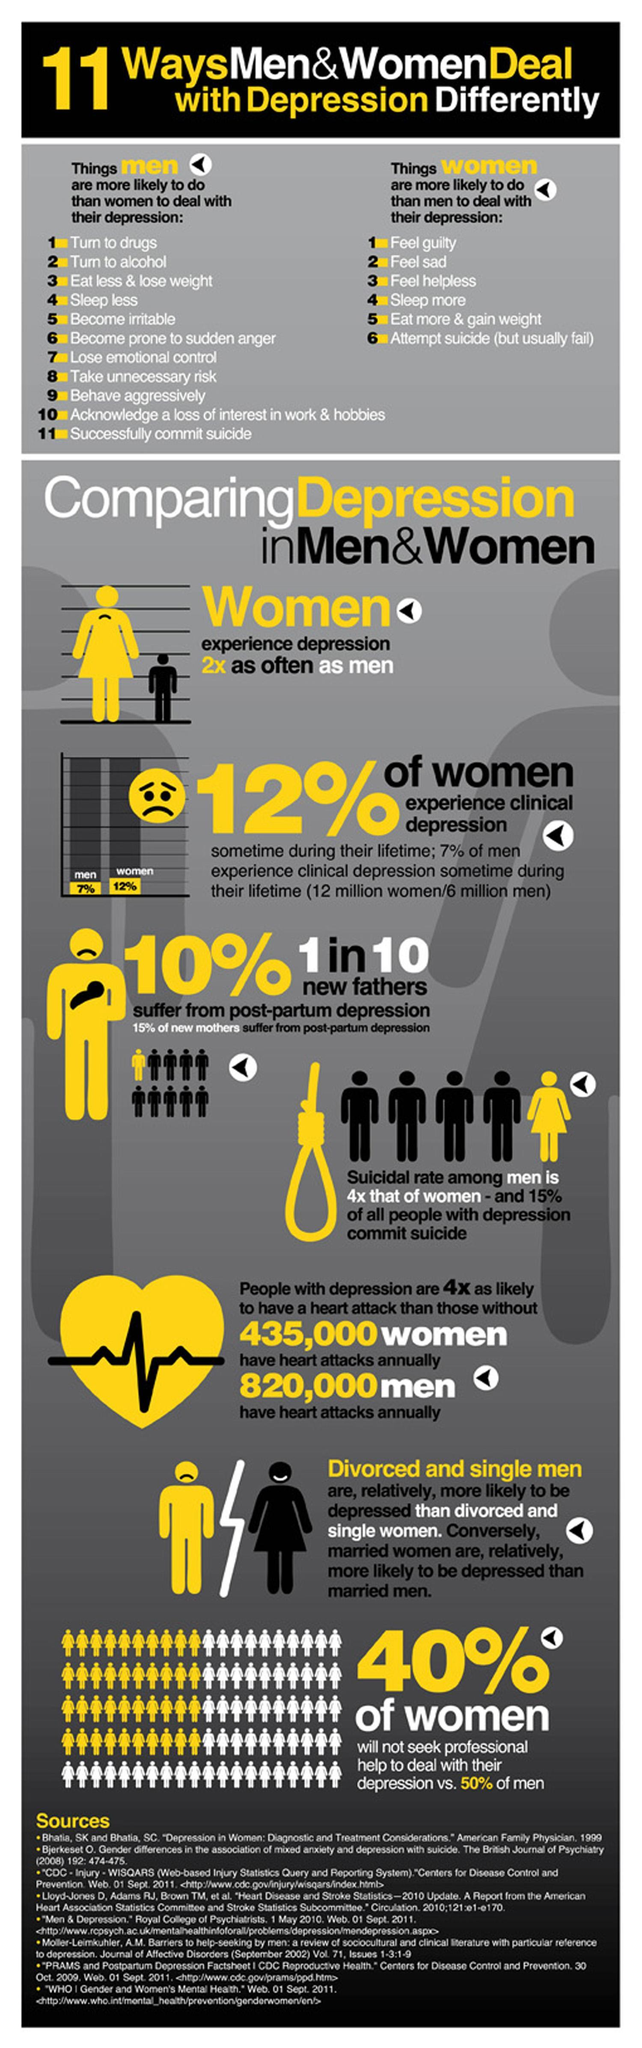Who will eat more and gain weight to deal with depression, men or women?
Answer the question with a short phrase. Women How many men experience clinical depression at least once in their lifetime? 6 million Who will eat less and lose weight to deal with depression, men or women? Men What percentage of men are against seeking professional help to deal with depression? 50% How many "times" more, is the suicidal rate in men higher than the suicidal rate in women? 4 Who are more likely to be depressed, married men or married women? Married women Who are more prone to depression, men or women? Women Out of every ten new fathers, how many are likely to suffer from postpartum depression? 1 Among whom is the suicide rates higher, men or women? Men Who are more likely to be depressed, divorced men or divorced women? Divorced men How many women experience clinical depression at least once in their lifetime? 12 million What percent of women are ready to seek professional help to deal with depression? 60% Who are more likely to suffer from postpartum depression, new mothers or new fathers? New mothers What percent of women are against seeking professional help to deal with depression? 40% 